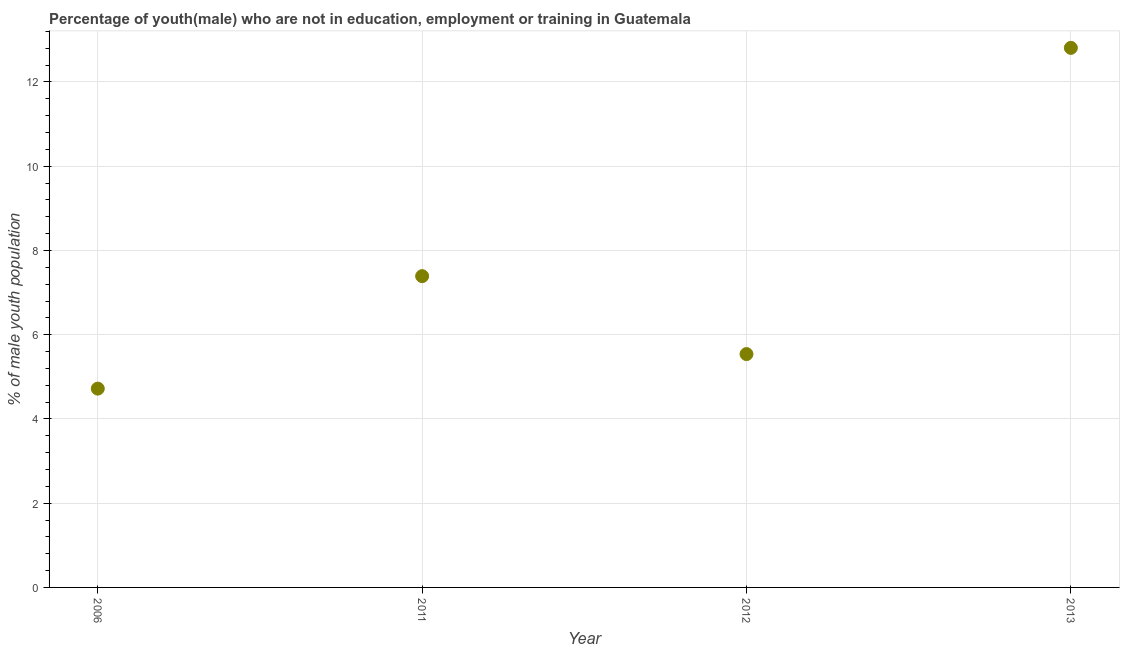What is the unemployed male youth population in 2006?
Ensure brevity in your answer.  4.72. Across all years, what is the maximum unemployed male youth population?
Provide a short and direct response. 12.81. Across all years, what is the minimum unemployed male youth population?
Make the answer very short. 4.72. In which year was the unemployed male youth population maximum?
Your answer should be compact. 2013. In which year was the unemployed male youth population minimum?
Your response must be concise. 2006. What is the sum of the unemployed male youth population?
Make the answer very short. 30.46. What is the difference between the unemployed male youth population in 2006 and 2012?
Keep it short and to the point. -0.82. What is the average unemployed male youth population per year?
Your response must be concise. 7.62. What is the median unemployed male youth population?
Keep it short and to the point. 6.46. What is the ratio of the unemployed male youth population in 2006 to that in 2012?
Offer a terse response. 0.85. Is the unemployed male youth population in 2011 less than that in 2012?
Offer a terse response. No. Is the difference between the unemployed male youth population in 2011 and 2013 greater than the difference between any two years?
Ensure brevity in your answer.  No. What is the difference between the highest and the second highest unemployed male youth population?
Your answer should be compact. 5.42. Is the sum of the unemployed male youth population in 2011 and 2012 greater than the maximum unemployed male youth population across all years?
Your response must be concise. Yes. What is the difference between the highest and the lowest unemployed male youth population?
Your response must be concise. 8.09. In how many years, is the unemployed male youth population greater than the average unemployed male youth population taken over all years?
Make the answer very short. 1. How many dotlines are there?
Offer a very short reply. 1. Are the values on the major ticks of Y-axis written in scientific E-notation?
Keep it short and to the point. No. Does the graph contain any zero values?
Give a very brief answer. No. Does the graph contain grids?
Provide a succinct answer. Yes. What is the title of the graph?
Your response must be concise. Percentage of youth(male) who are not in education, employment or training in Guatemala. What is the label or title of the X-axis?
Offer a terse response. Year. What is the label or title of the Y-axis?
Provide a succinct answer. % of male youth population. What is the % of male youth population in 2006?
Ensure brevity in your answer.  4.72. What is the % of male youth population in 2011?
Offer a very short reply. 7.39. What is the % of male youth population in 2012?
Keep it short and to the point. 5.54. What is the % of male youth population in 2013?
Provide a short and direct response. 12.81. What is the difference between the % of male youth population in 2006 and 2011?
Offer a terse response. -2.67. What is the difference between the % of male youth population in 2006 and 2012?
Offer a very short reply. -0.82. What is the difference between the % of male youth population in 2006 and 2013?
Make the answer very short. -8.09. What is the difference between the % of male youth population in 2011 and 2012?
Your answer should be compact. 1.85. What is the difference between the % of male youth population in 2011 and 2013?
Keep it short and to the point. -5.42. What is the difference between the % of male youth population in 2012 and 2013?
Your response must be concise. -7.27. What is the ratio of the % of male youth population in 2006 to that in 2011?
Provide a short and direct response. 0.64. What is the ratio of the % of male youth population in 2006 to that in 2012?
Offer a terse response. 0.85. What is the ratio of the % of male youth population in 2006 to that in 2013?
Provide a succinct answer. 0.37. What is the ratio of the % of male youth population in 2011 to that in 2012?
Ensure brevity in your answer.  1.33. What is the ratio of the % of male youth population in 2011 to that in 2013?
Ensure brevity in your answer.  0.58. What is the ratio of the % of male youth population in 2012 to that in 2013?
Offer a very short reply. 0.43. 